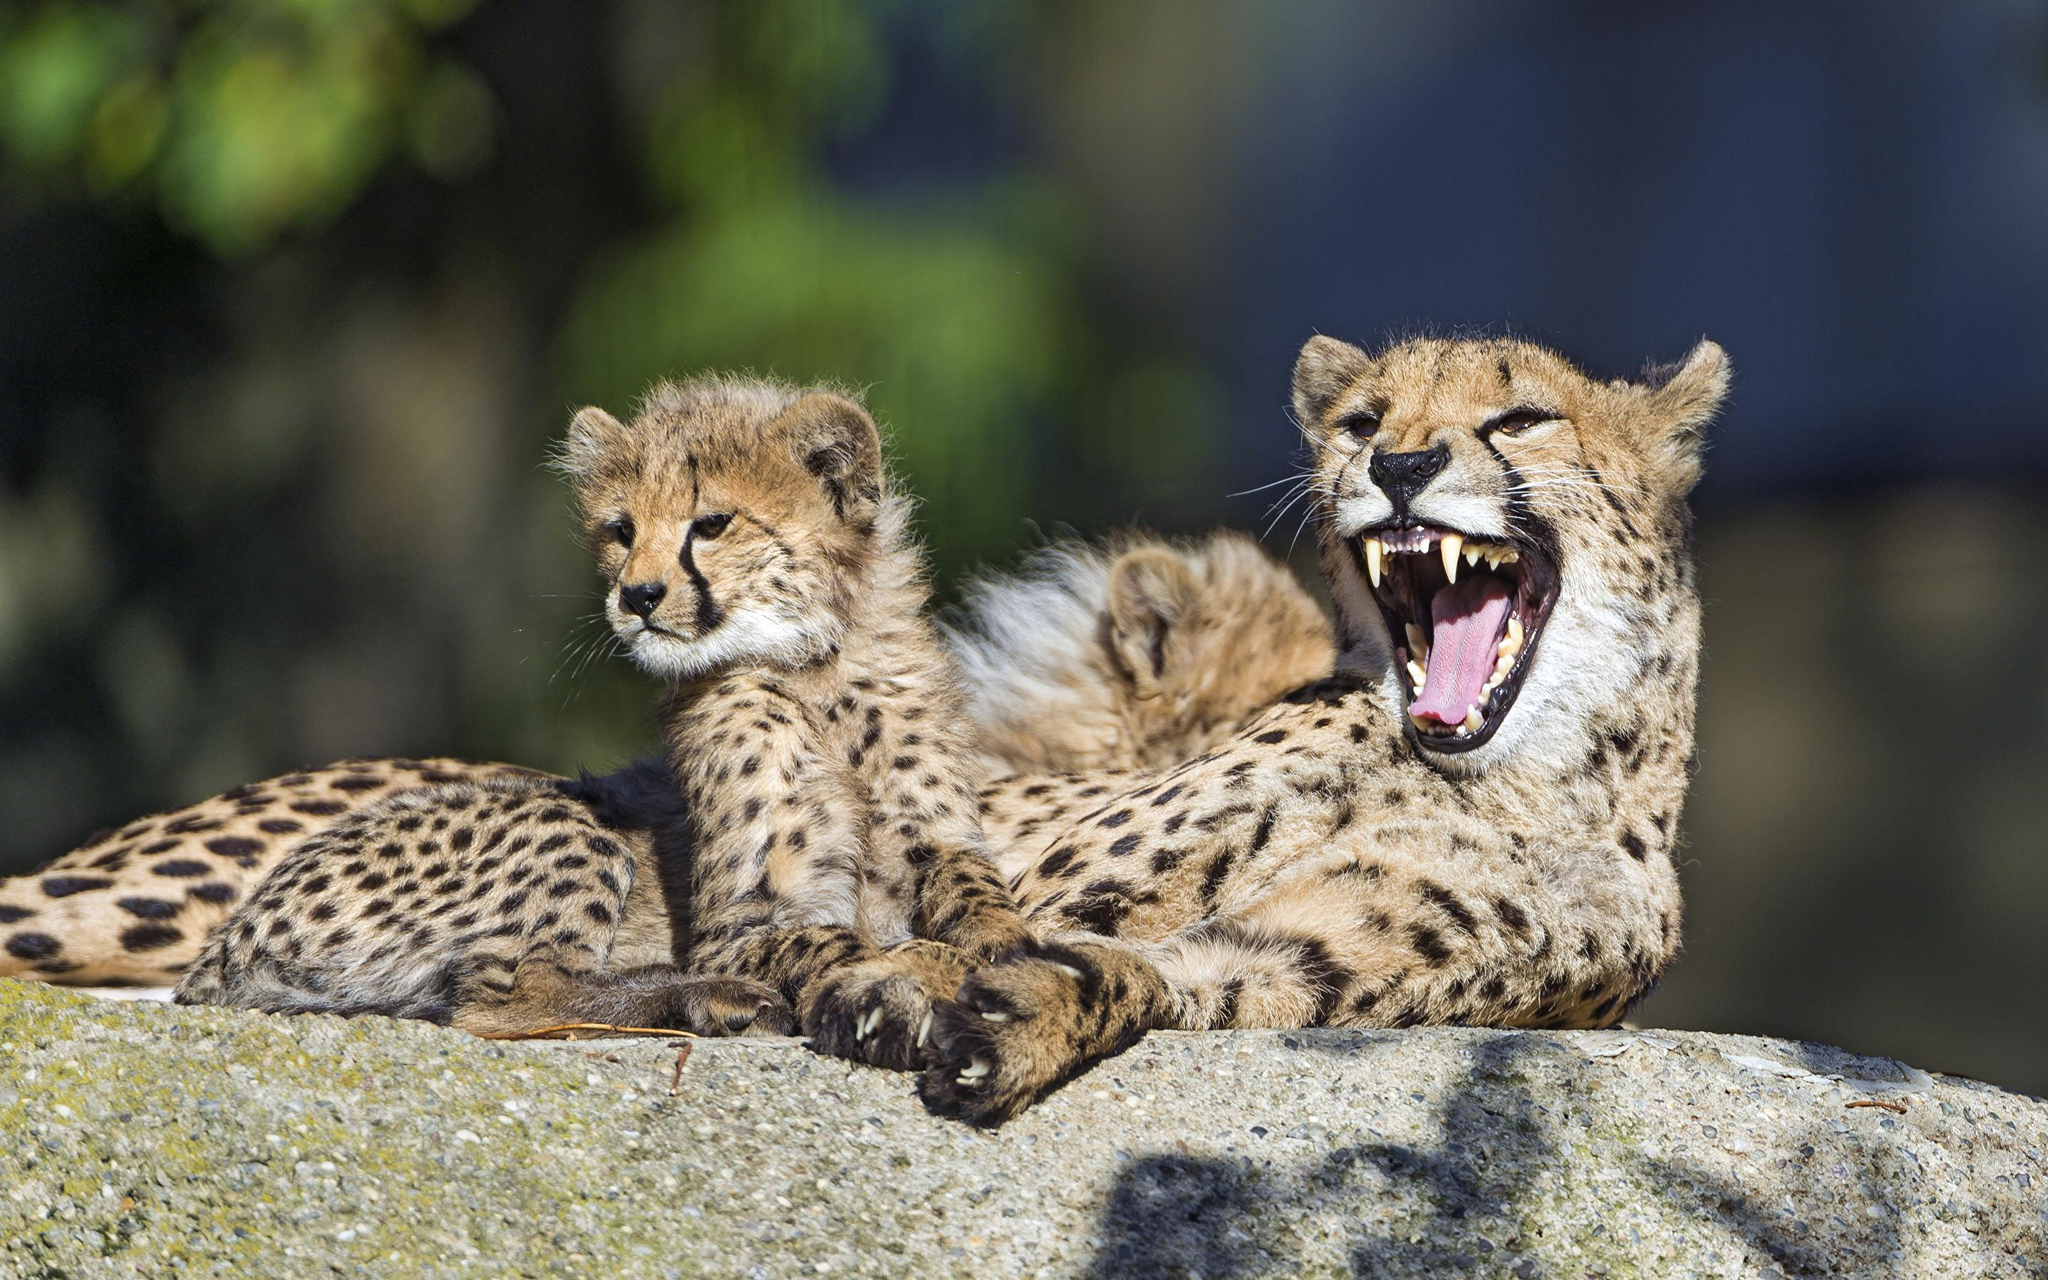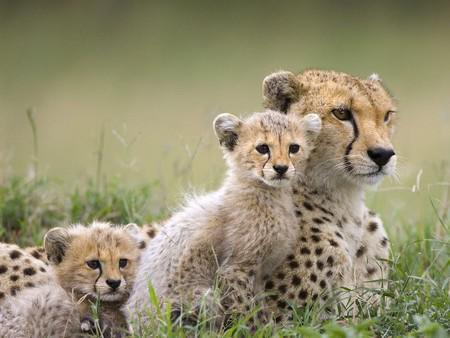The first image is the image on the left, the second image is the image on the right. Examine the images to the left and right. Is the description "the right pic has two cheetahs" accurate? Answer yes or no. No. The first image is the image on the left, the second image is the image on the right. Analyze the images presented: Is the assertion "A cheetah is yawning." valid? Answer yes or no. Yes. 